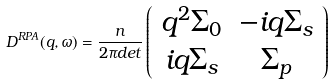<formula> <loc_0><loc_0><loc_500><loc_500>D ^ { R P A } ( { q } , \omega ) = \frac { n } { 2 \pi d e t } \left ( \begin{array} { c c } q ^ { 2 } \Sigma _ { 0 } & - i q \Sigma _ { s } \\ i q \Sigma _ { s } & \Sigma _ { p } \end{array} \right )</formula> 